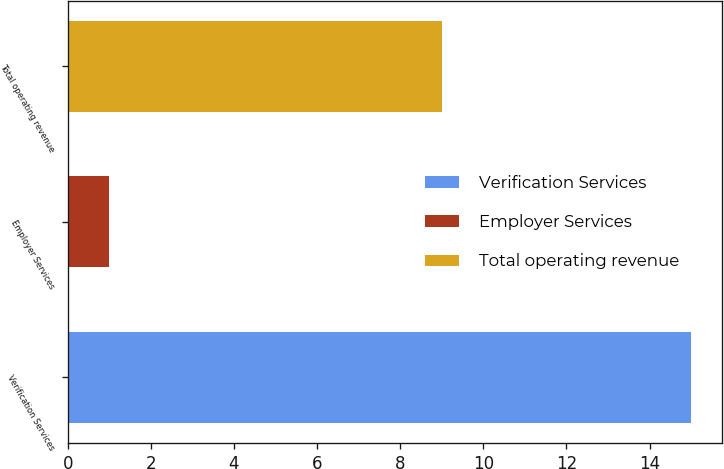<chart> <loc_0><loc_0><loc_500><loc_500><bar_chart><fcel>Verification Services<fcel>Employer Services<fcel>Total operating revenue<nl><fcel>15<fcel>1<fcel>9<nl></chart> 